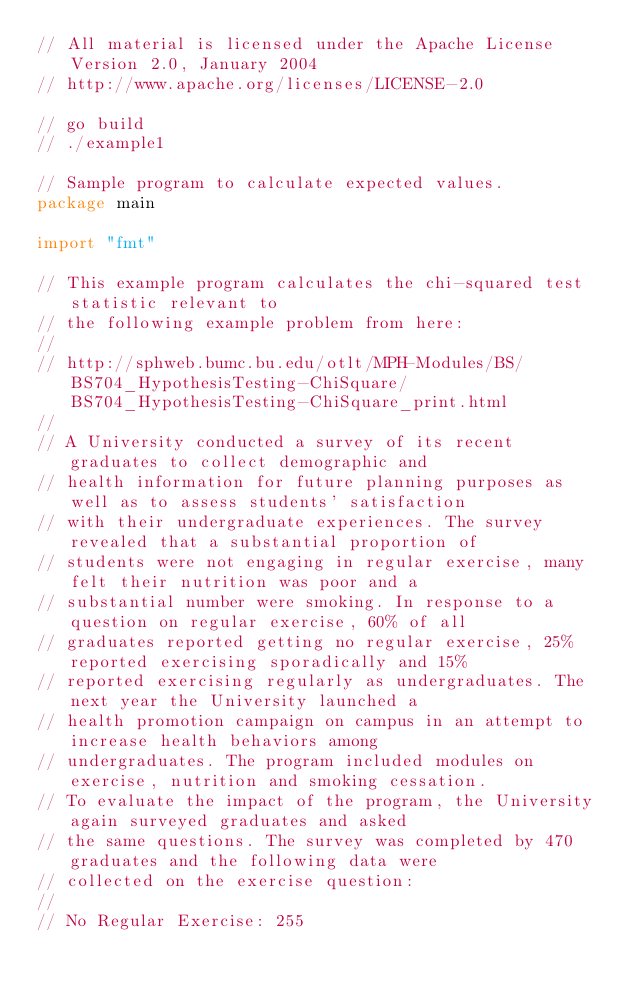<code> <loc_0><loc_0><loc_500><loc_500><_Go_>// All material is licensed under the Apache License Version 2.0, January 2004
// http://www.apache.org/licenses/LICENSE-2.0

// go build
// ./example1

// Sample program to calculate expected values.
package main

import "fmt"

// This example program calculates the chi-squared test statistic relevant to
// the following example problem from here:
//
// http://sphweb.bumc.bu.edu/otlt/MPH-Modules/BS/BS704_HypothesisTesting-ChiSquare/BS704_HypothesisTesting-ChiSquare_print.html
//
// A University conducted a survey of its recent graduates to collect demographic and
// health information for future planning purposes as well as to assess students' satisfaction
// with their undergraduate experiences. The survey revealed that a substantial proportion of
// students were not engaging in regular exercise, many felt their nutrition was poor and a
// substantial number were smoking. In response to a question on regular exercise, 60% of all
// graduates reported getting no regular exercise, 25% reported exercising sporadically and 15%
// reported exercising regularly as undergraduates. The next year the University launched a
// health promotion campaign on campus in an attempt to increase health behaviors among
// undergraduates. The program included modules on exercise, nutrition and smoking cessation.
// To evaluate the impact of the program, the University again surveyed graduates and asked
// the same questions. The survey was completed by 470 graduates and the following data were
// collected on the exercise question:
//
// No Regular Exercise: 255</code> 